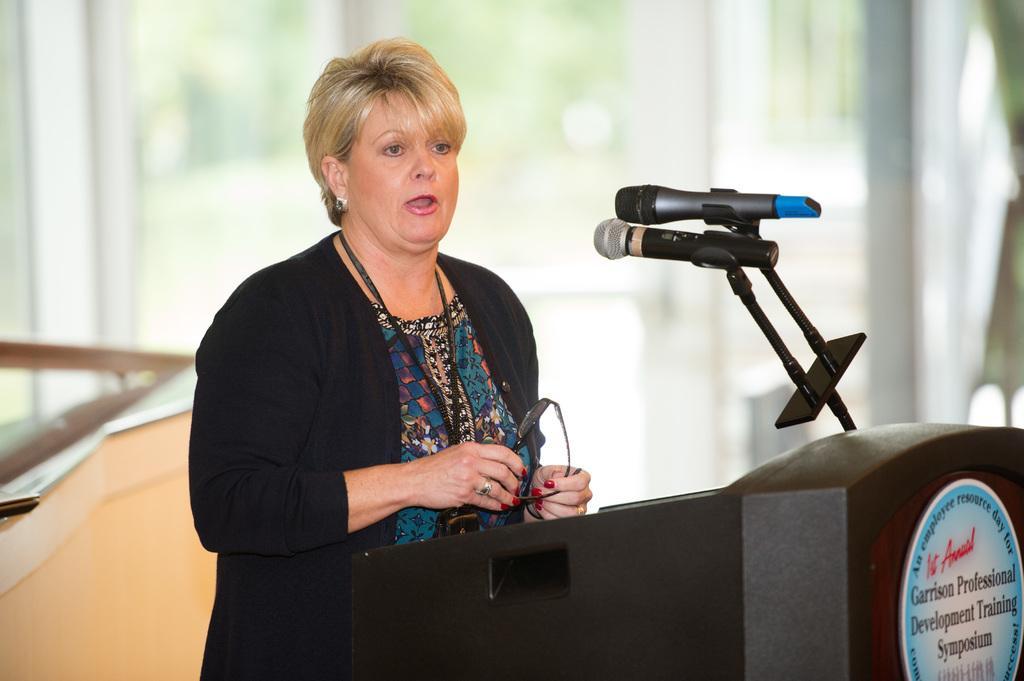Could you give a brief overview of what you see in this image? In this image I can see a woman is standing in front of a podium. Here I can see microphones. The background of the image is blurred. 